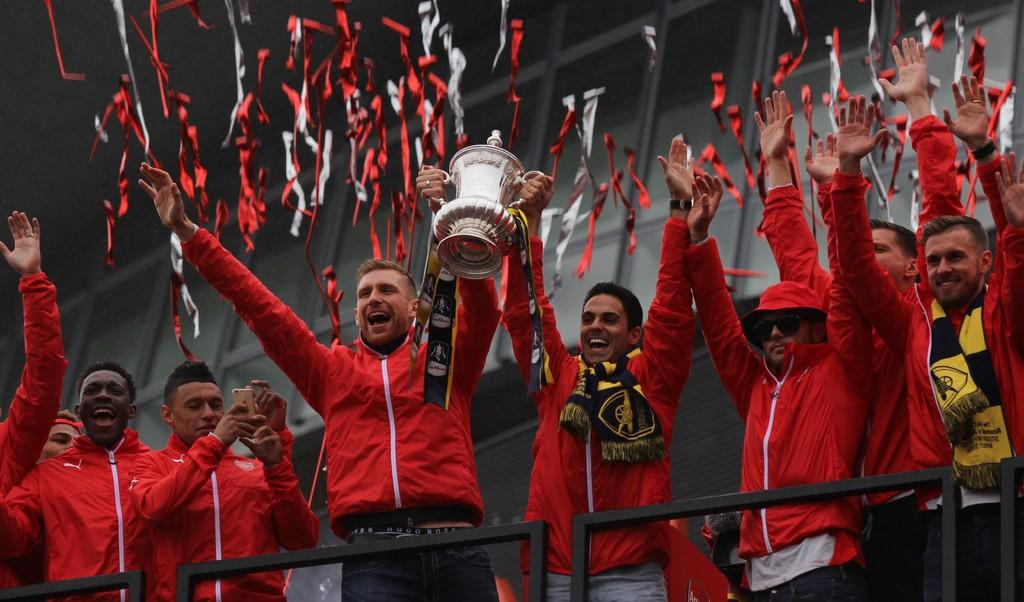Who or what is present in the image? There are people in the image. What are the people holding in the image? The people are holding a trophy. What are the people wearing in the image? The people are wearing red jackets. What can be seen at the bottom of the image? There are grills at the bottom of the image. What can be seen in the background of the image? There are decorations in the background of the image. How many lizards are sitting on the trophy in the image? There are no lizards present in the image. What type of bulb is used to light up the decorations in the background? There is no mention of a bulb or lighting in the image; it only shows decorations in the background. 